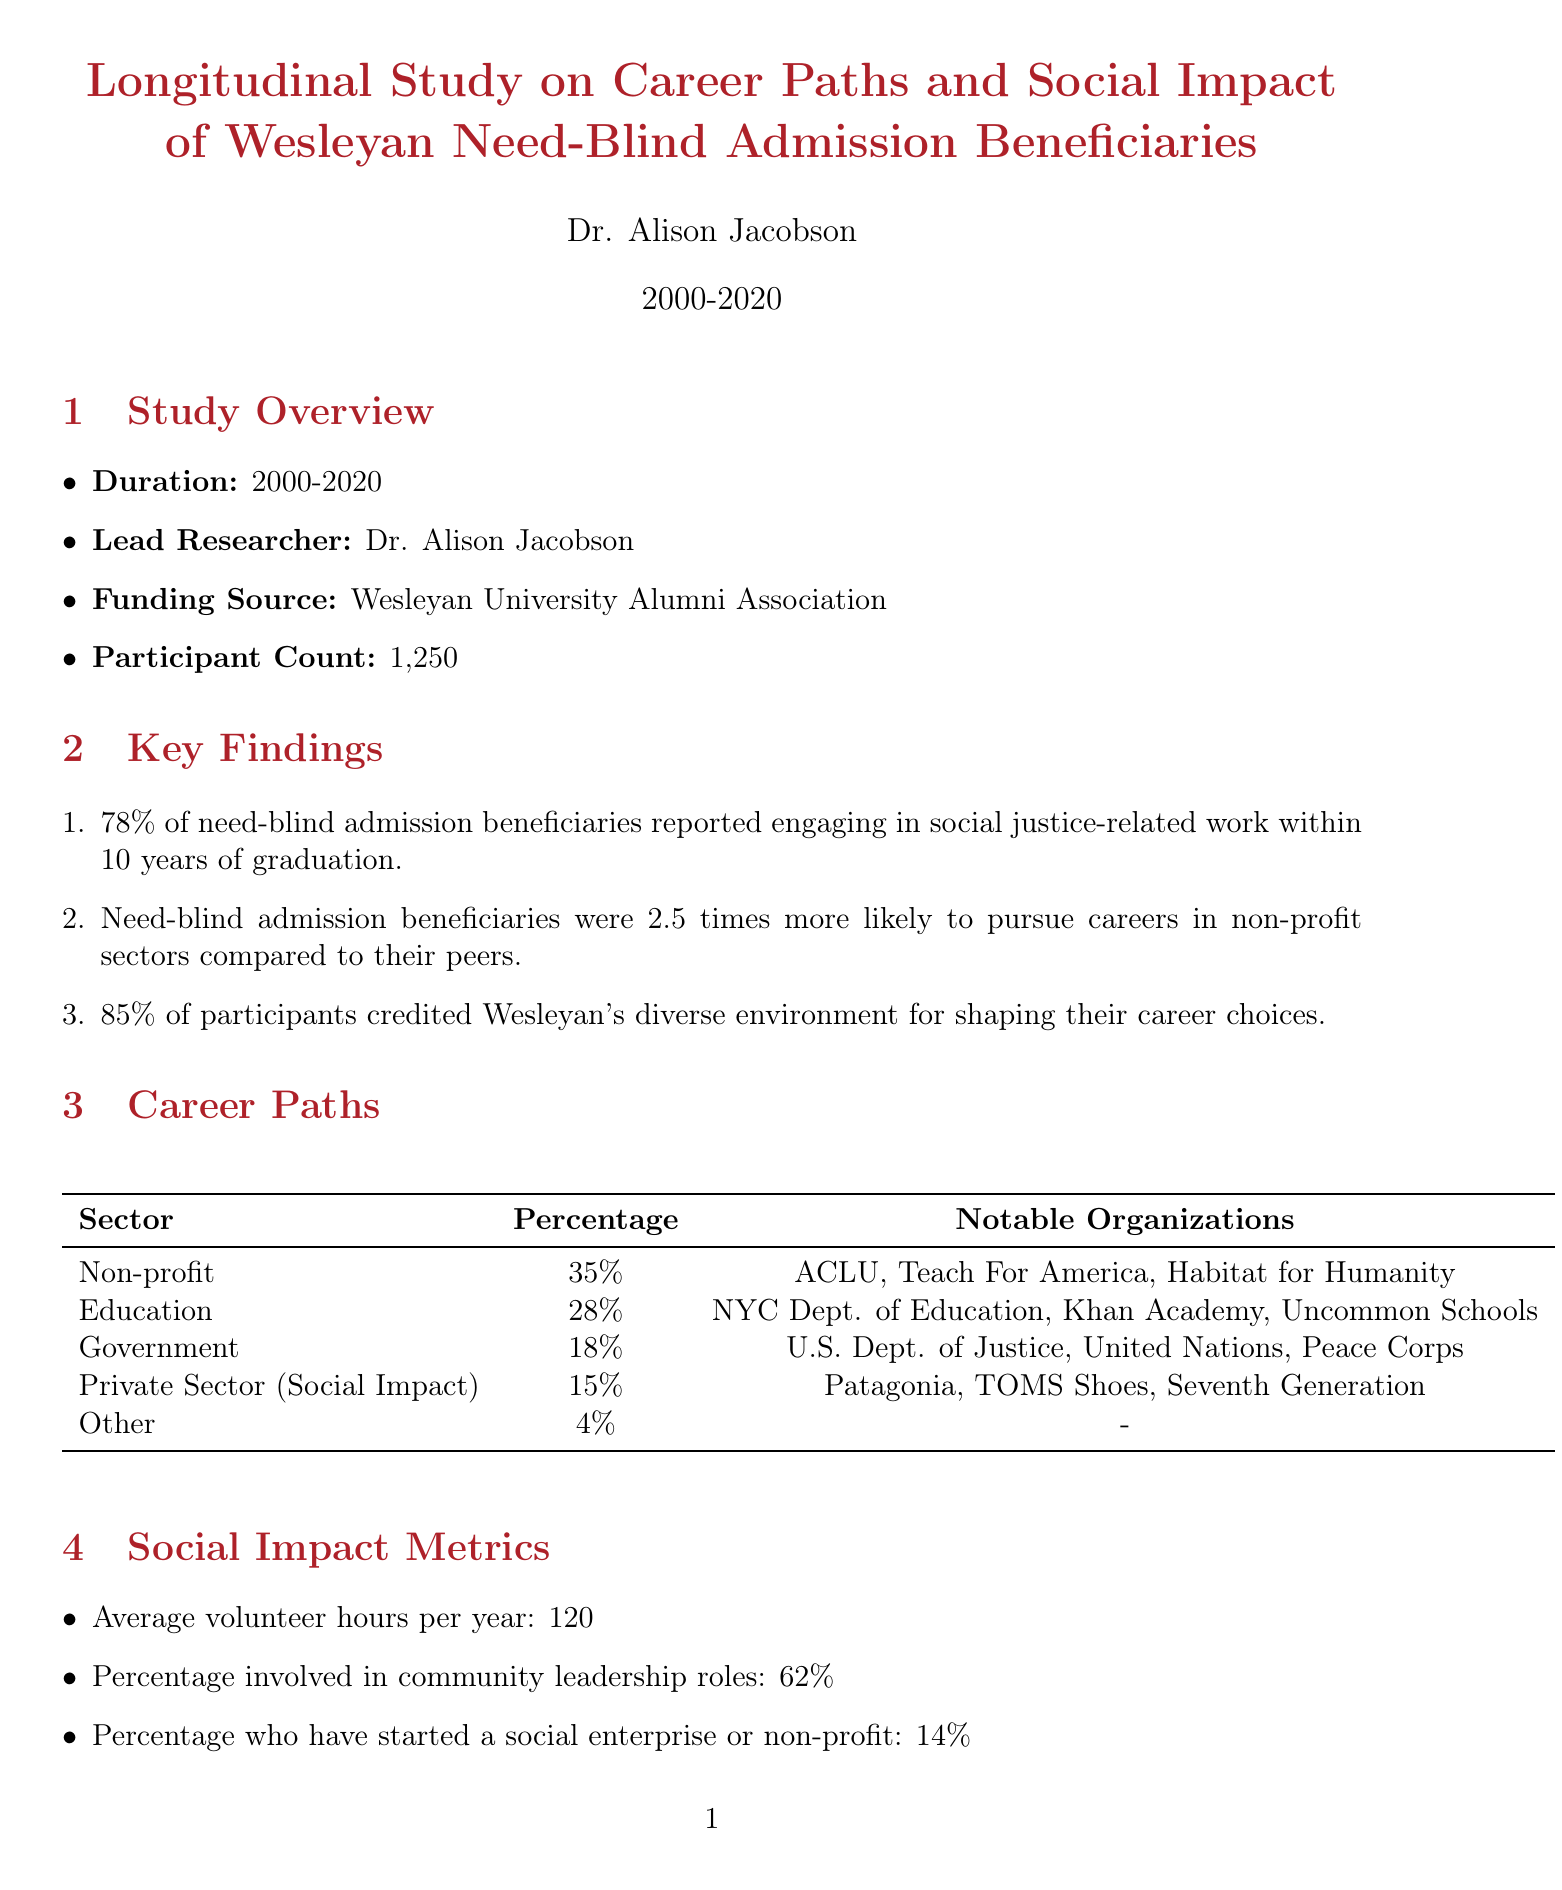What is the title of the study? The title is given in the document's header, indicating the overall focus of the research.
Answer: Longitudinal Study on Career Paths and Social Impact of Wesleyan Need-Blind Admission Beneficiaries Who is the lead researcher? The document specifies the individual overseeing the study, which is crucial for identifying expertise.
Answer: Dr. Alison Jacobson What percentage of beneficiaries engaged in social justice-related work within 10 years? The document highlights a key finding regarding the career choices of graduates benefiting from need-blind admissions.
Answer: 78% What percentage of participants have started a social enterprise or non-profit? This question addresses the social impact metrics presented in the document.
Answer: 14% Which organization is noted for employing a 2005 graduate in environmental justice? This identifies a specific alumni example with an impactful career after graduating.
Answer: EarthJustice How many participants were involved in the study? This number indicates the scale of the research and its relevance.
Answer: 1250 What is the recommended action to maintain need-blind admissions? The document lists challenges and recommendations, focusing on how to preserve the admissions policy.
Answer: Increase alumni engagement and donations specifically for need-blind admissions fund Which sector has the highest percentage of alumni working in non-profit organizations? Understanding the sectors of employment helps assess the impact of the educational values instilled during their education.
Answer: Non-profit What percentage of alumni are involved in community leadership roles? This figure demonstrates engagement in local governance and service, reflecting the graduates' commitment to social impact.
Answer: 62% 